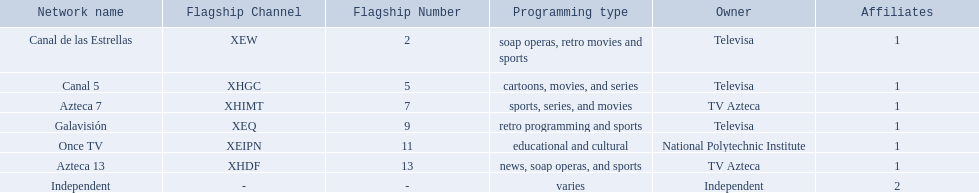What are each of the networks? Canal de las Estrellas, Canal 5, Azteca 7, Galavisión, Once TV, Azteca 13, Independent. Who owns them? Televisa, Televisa, TV Azteca, Televisa, National Polytechnic Institute, TV Azteca, Independent. Parse the full table in json format. {'header': ['Network name', 'Flagship Channel', 'Flagship Number', 'Programming type', 'Owner', 'Affiliates'], 'rows': [['Canal de las Estrellas', 'XEW', '2', 'soap operas, retro movies and sports', 'Televisa', '1'], ['Canal 5', 'XHGC', '5', 'cartoons, movies, and series', 'Televisa', '1'], ['Azteca 7', 'XHIMT', '7', 'sports, series, and movies', 'TV Azteca', '1'], ['Galavisión', 'XEQ', '9', 'retro programming and sports', 'Televisa', '1'], ['Once TV', 'XEIPN', '11', 'educational and cultural', 'National Polytechnic Institute', '1'], ['Azteca 13', 'XHDF', '13', 'news, soap operas, and sports', 'TV Azteca', '1'], ['Independent', '-', '-', 'varies', 'Independent', '2']]} Which networks aren't owned by televisa? Azteca 7, Once TV, Azteca 13, Independent. What type of programming do those networks offer? Sports, series, and movies, educational and cultural, news, soap operas, and sports, varies. And which network is the only one with sports? Azteca 7. 